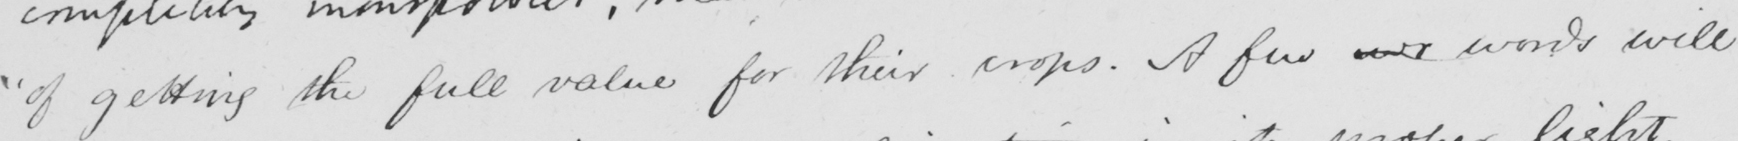What is written in this line of handwriting? " of getting the full value for their crops . A few wo words will 